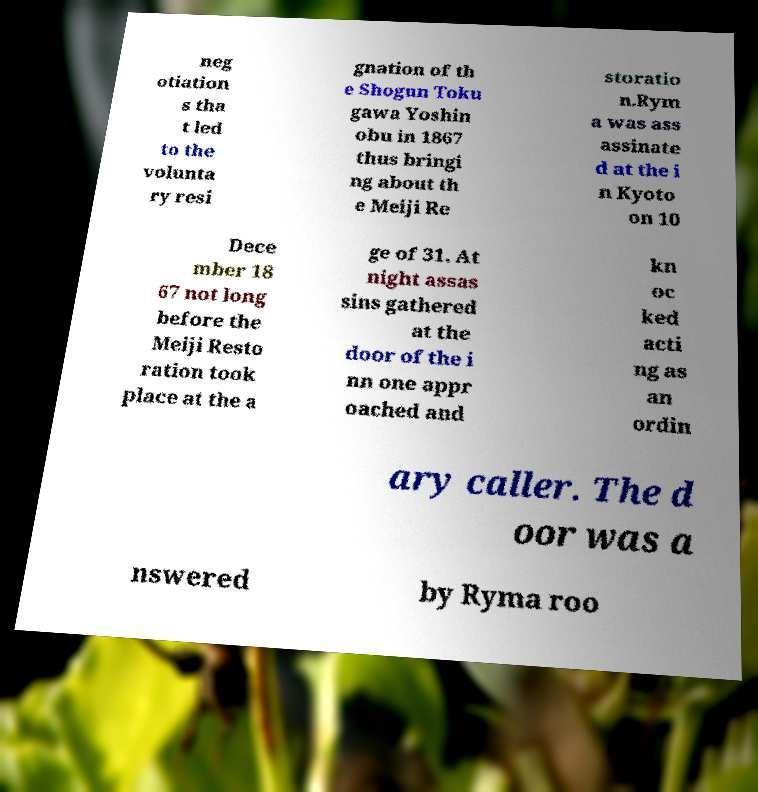Please read and relay the text visible in this image. What does it say? neg otiation s tha t led to the volunta ry resi gnation of th e Shogun Toku gawa Yoshin obu in 1867 thus bringi ng about th e Meiji Re storatio n.Rym a was ass assinate d at the i n Kyoto on 10 Dece mber 18 67 not long before the Meiji Resto ration took place at the a ge of 31. At night assas sins gathered at the door of the i nn one appr oached and kn oc ked acti ng as an ordin ary caller. The d oor was a nswered by Ryma roo 